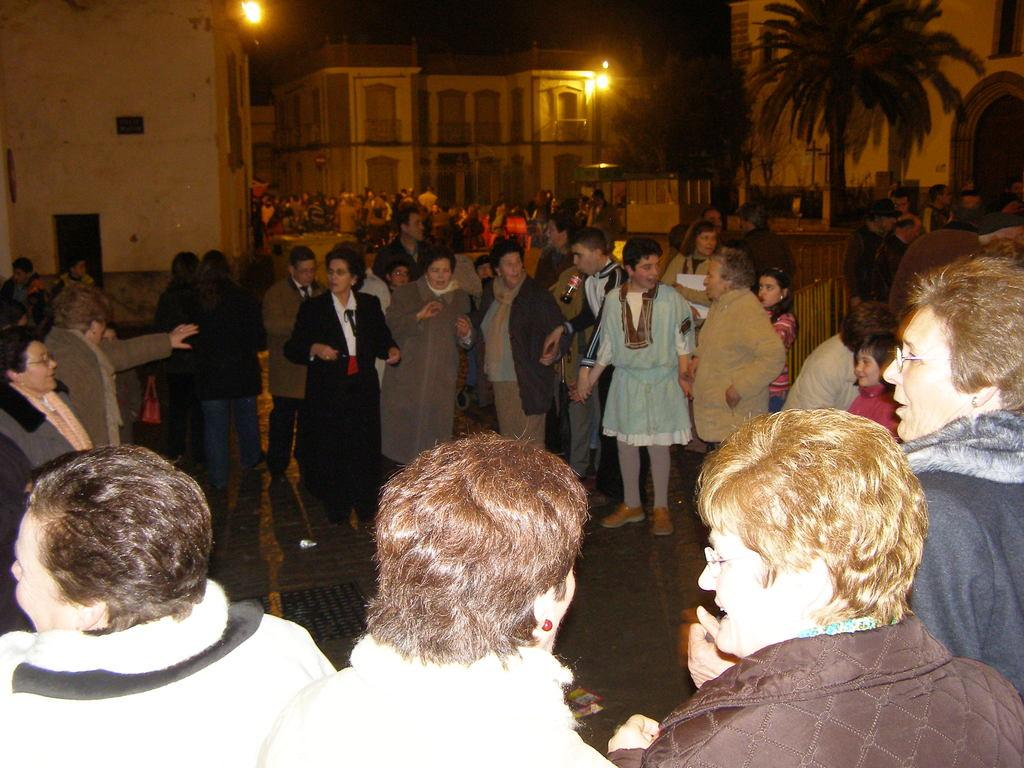What can be seen on the path in the image? There are many people standing on the path in the image. What structures are visible with lights in the image? There are buildings with lights in the image. What type of natural elements can be seen in the image? There are trees in the image. What type of lip can be seen on the trees in the image? There are no lips present on the trees in the image. What vegetables are being grown in the image? There is no indication of any vegetables being grown in the image. 